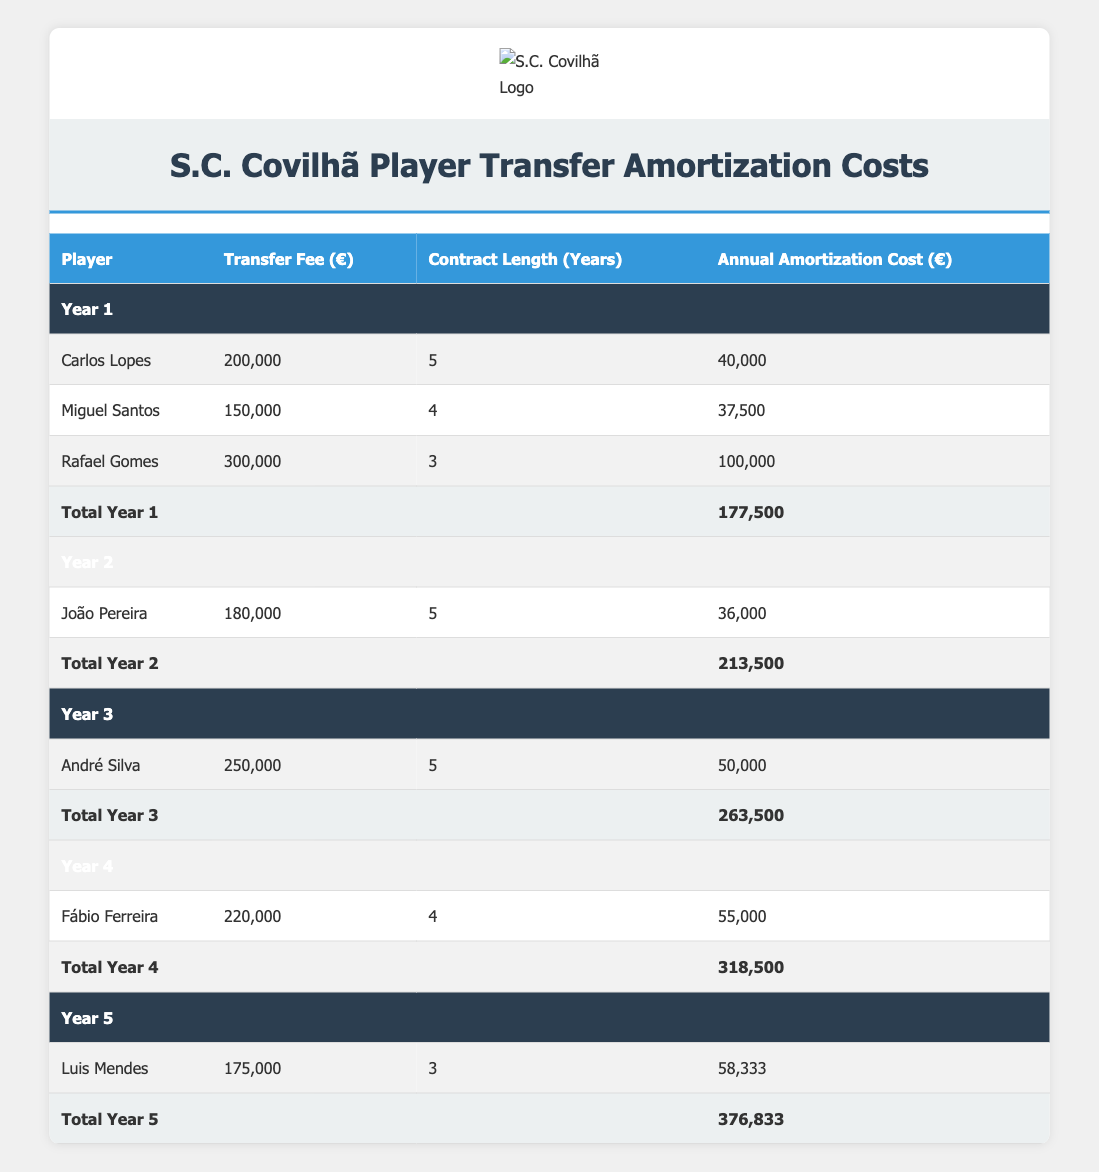What is the annual amortization cost for Rafael Gomes? According to the table, the annual amortization cost for Rafael Gomes is listed directly in the "Annual Amortization Cost (€)" column for Year 1, which shows 100,000.
Answer: 100,000 Which player has the highest transfer fee? To determine the player with the highest transfer fee, we can compare the values listed in the "Transfer Fee (€)" column. Rafael Gomes has a transfer fee of 300,000, which is the highest among all players.
Answer: Rafael Gomes What is the total annual amortization cost for Year 2? The total for Year 2 is calculated by adding the annual amortization costs for each player in that year. The only player listed for Year 2, João Pereira, has an annual amortization cost of 36,000. As there are no other players, the total is 36,000.
Answer: 213,500 Is the annual amortization cost for André Silva greater than that of Carlos Lopes? The annual amortization cost for André Silva is 50,000, while for Carlos Lopes, it is 40,000. Since 50,000 is greater than 40,000, the answer is yes.
Answer: Yes What is the average annual amortization cost for the players listed in Year 1? To find the average, we first sum the annual amortization costs of all players in Year 1: 40,000 (Carlos Lopes) + 37,500 (Miguel Santos) + 100,000 (Rafael Gomes) = 177,500. There are 3 players, so the average is 177,500 / 3 = 59,166.67.
Answer: 59,166.67 Which year has the highest total amortization cost, and what is that value? To find the year with the highest total amortization cost, we need to look at the total rows for each year. The totals are 177,500 for Year 1, 213,500 for Year 2, 263,500 for Year 3, 318,500 for Year 4, and 376,833 for Year 5. The highest is Year 5 at 376,833.
Answer: Year 5, 376,833 Does Luis Mendes have a longer contract than Miguel Santos? Luis Mendes's contract length is 3 years, while Miguel Santos's contract length is 4 years. Since 3 is less than 4, the statement is false.
Answer: No What is the total amortization cost incurred by S.C. Covilhã over the entire 5-year period? To calculate the total amortization cost over the 5 years, we must sum the total amortization costs from each year. This includes: Year 1 (177,500) + Year 2 (213,500) + Year 3 (263,500) + Year 4 (318,500) + Year 5 (376,833) = 1,349,833.
Answer: 1,349,833 What amount was invested in players who have a contract length of 5 years? The players with a contract length of 5 years are Carlos Lopes, João Pereira, and André Silva. Their respective transfer fees are 200,000, 180,000, and 250,000. Summing these values gives 200,000 + 180,000 + 250,000 = 630,000.
Answer: 630,000 